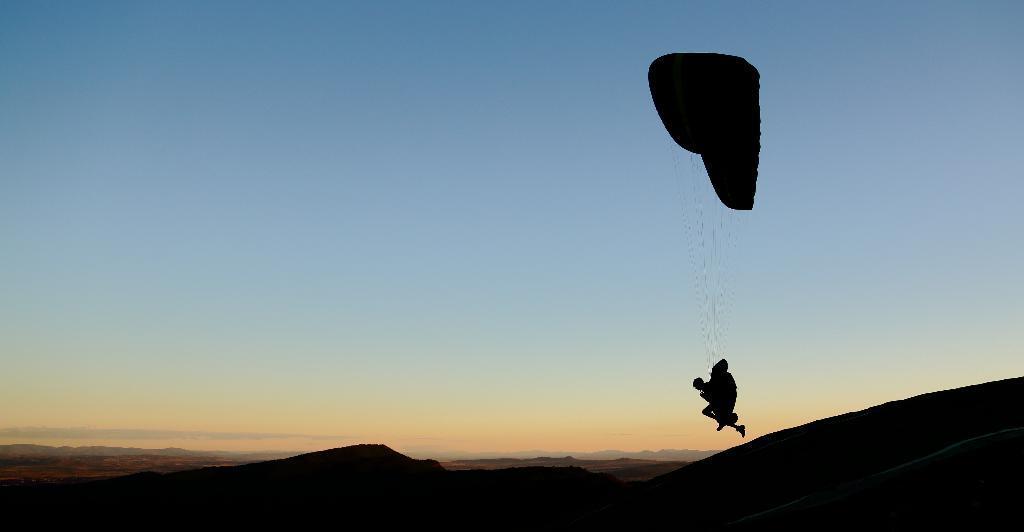In one or two sentences, can you explain what this image depicts? In this picture I can observe a parachute on the right side. There are some hills on the bottom of the picture. In the background there is sky. 